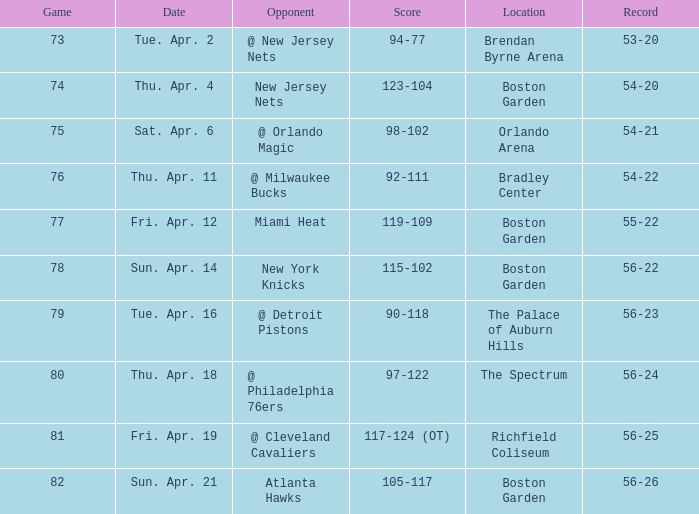At what point was the score 56-26? Sun. Apr. 21. 